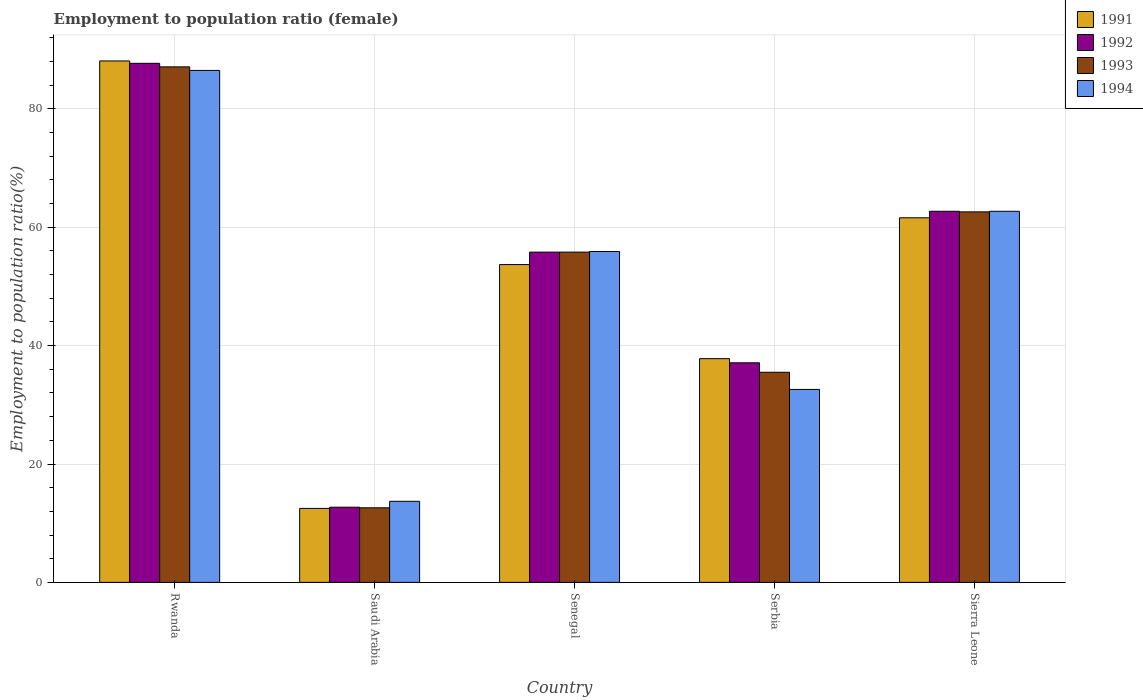How many different coloured bars are there?
Provide a succinct answer. 4. Are the number of bars per tick equal to the number of legend labels?
Provide a short and direct response. Yes. Are the number of bars on each tick of the X-axis equal?
Ensure brevity in your answer.  Yes. How many bars are there on the 3rd tick from the right?
Keep it short and to the point. 4. What is the label of the 4th group of bars from the left?
Offer a terse response. Serbia. What is the employment to population ratio in 1992 in Sierra Leone?
Provide a succinct answer. 62.7. Across all countries, what is the maximum employment to population ratio in 1993?
Make the answer very short. 87.1. Across all countries, what is the minimum employment to population ratio in 1994?
Give a very brief answer. 13.7. In which country was the employment to population ratio in 1991 maximum?
Offer a terse response. Rwanda. In which country was the employment to population ratio in 1992 minimum?
Make the answer very short. Saudi Arabia. What is the total employment to population ratio in 1991 in the graph?
Provide a short and direct response. 253.7. What is the difference between the employment to population ratio in 1994 in Rwanda and that in Saudi Arabia?
Provide a succinct answer. 72.8. What is the difference between the employment to population ratio in 1991 in Rwanda and the employment to population ratio in 1993 in Saudi Arabia?
Ensure brevity in your answer.  75.5. What is the average employment to population ratio in 1991 per country?
Your response must be concise. 50.74. What is the difference between the employment to population ratio of/in 1994 and employment to population ratio of/in 1992 in Rwanda?
Your answer should be compact. -1.2. In how many countries, is the employment to population ratio in 1992 greater than 52 %?
Offer a very short reply. 3. What is the ratio of the employment to population ratio in 1994 in Saudi Arabia to that in Sierra Leone?
Provide a short and direct response. 0.22. Is the employment to population ratio in 1994 in Saudi Arabia less than that in Sierra Leone?
Provide a short and direct response. Yes. What is the difference between the highest and the second highest employment to population ratio in 1992?
Give a very brief answer. -6.9. What is the difference between the highest and the lowest employment to population ratio in 1993?
Provide a succinct answer. 74.5. In how many countries, is the employment to population ratio in 1993 greater than the average employment to population ratio in 1993 taken over all countries?
Your response must be concise. 3. Is the sum of the employment to population ratio in 1992 in Rwanda and Sierra Leone greater than the maximum employment to population ratio in 1993 across all countries?
Make the answer very short. Yes. Is it the case that in every country, the sum of the employment to population ratio in 1994 and employment to population ratio in 1993 is greater than the sum of employment to population ratio in 1991 and employment to population ratio in 1992?
Keep it short and to the point. No. What does the 4th bar from the left in Rwanda represents?
Provide a short and direct response. 1994. What does the 2nd bar from the right in Senegal represents?
Give a very brief answer. 1993. How many bars are there?
Your answer should be very brief. 20. Are the values on the major ticks of Y-axis written in scientific E-notation?
Your response must be concise. No. Does the graph contain any zero values?
Your answer should be compact. No. How many legend labels are there?
Your answer should be compact. 4. How are the legend labels stacked?
Make the answer very short. Vertical. What is the title of the graph?
Give a very brief answer. Employment to population ratio (female). Does "1966" appear as one of the legend labels in the graph?
Your response must be concise. No. What is the label or title of the Y-axis?
Your answer should be compact. Employment to population ratio(%). What is the Employment to population ratio(%) in 1991 in Rwanda?
Your response must be concise. 88.1. What is the Employment to population ratio(%) of 1992 in Rwanda?
Your answer should be compact. 87.7. What is the Employment to population ratio(%) in 1993 in Rwanda?
Provide a short and direct response. 87.1. What is the Employment to population ratio(%) of 1994 in Rwanda?
Keep it short and to the point. 86.5. What is the Employment to population ratio(%) in 1992 in Saudi Arabia?
Your answer should be compact. 12.7. What is the Employment to population ratio(%) in 1993 in Saudi Arabia?
Your answer should be compact. 12.6. What is the Employment to population ratio(%) in 1994 in Saudi Arabia?
Your response must be concise. 13.7. What is the Employment to population ratio(%) of 1991 in Senegal?
Your answer should be very brief. 53.7. What is the Employment to population ratio(%) of 1992 in Senegal?
Keep it short and to the point. 55.8. What is the Employment to population ratio(%) of 1993 in Senegal?
Your answer should be compact. 55.8. What is the Employment to population ratio(%) in 1994 in Senegal?
Make the answer very short. 55.9. What is the Employment to population ratio(%) of 1991 in Serbia?
Your answer should be very brief. 37.8. What is the Employment to population ratio(%) of 1992 in Serbia?
Provide a succinct answer. 37.1. What is the Employment to population ratio(%) in 1993 in Serbia?
Give a very brief answer. 35.5. What is the Employment to population ratio(%) in 1994 in Serbia?
Your response must be concise. 32.6. What is the Employment to population ratio(%) of 1991 in Sierra Leone?
Make the answer very short. 61.6. What is the Employment to population ratio(%) in 1992 in Sierra Leone?
Give a very brief answer. 62.7. What is the Employment to population ratio(%) of 1993 in Sierra Leone?
Give a very brief answer. 62.6. What is the Employment to population ratio(%) of 1994 in Sierra Leone?
Your response must be concise. 62.7. Across all countries, what is the maximum Employment to population ratio(%) of 1991?
Keep it short and to the point. 88.1. Across all countries, what is the maximum Employment to population ratio(%) of 1992?
Your answer should be compact. 87.7. Across all countries, what is the maximum Employment to population ratio(%) in 1993?
Offer a very short reply. 87.1. Across all countries, what is the maximum Employment to population ratio(%) in 1994?
Your response must be concise. 86.5. Across all countries, what is the minimum Employment to population ratio(%) in 1991?
Keep it short and to the point. 12.5. Across all countries, what is the minimum Employment to population ratio(%) of 1992?
Provide a succinct answer. 12.7. Across all countries, what is the minimum Employment to population ratio(%) of 1993?
Give a very brief answer. 12.6. Across all countries, what is the minimum Employment to population ratio(%) in 1994?
Make the answer very short. 13.7. What is the total Employment to population ratio(%) in 1991 in the graph?
Your response must be concise. 253.7. What is the total Employment to population ratio(%) in 1992 in the graph?
Ensure brevity in your answer.  256. What is the total Employment to population ratio(%) in 1993 in the graph?
Provide a short and direct response. 253.6. What is the total Employment to population ratio(%) in 1994 in the graph?
Keep it short and to the point. 251.4. What is the difference between the Employment to population ratio(%) in 1991 in Rwanda and that in Saudi Arabia?
Offer a terse response. 75.6. What is the difference between the Employment to population ratio(%) in 1993 in Rwanda and that in Saudi Arabia?
Offer a terse response. 74.5. What is the difference between the Employment to population ratio(%) of 1994 in Rwanda and that in Saudi Arabia?
Provide a short and direct response. 72.8. What is the difference between the Employment to population ratio(%) of 1991 in Rwanda and that in Senegal?
Provide a short and direct response. 34.4. What is the difference between the Employment to population ratio(%) of 1992 in Rwanda and that in Senegal?
Keep it short and to the point. 31.9. What is the difference between the Employment to population ratio(%) in 1993 in Rwanda and that in Senegal?
Provide a short and direct response. 31.3. What is the difference between the Employment to population ratio(%) of 1994 in Rwanda and that in Senegal?
Offer a terse response. 30.6. What is the difference between the Employment to population ratio(%) in 1991 in Rwanda and that in Serbia?
Ensure brevity in your answer.  50.3. What is the difference between the Employment to population ratio(%) in 1992 in Rwanda and that in Serbia?
Offer a very short reply. 50.6. What is the difference between the Employment to population ratio(%) in 1993 in Rwanda and that in Serbia?
Give a very brief answer. 51.6. What is the difference between the Employment to population ratio(%) in 1994 in Rwanda and that in Serbia?
Offer a terse response. 53.9. What is the difference between the Employment to population ratio(%) of 1992 in Rwanda and that in Sierra Leone?
Your response must be concise. 25. What is the difference between the Employment to population ratio(%) in 1994 in Rwanda and that in Sierra Leone?
Make the answer very short. 23.8. What is the difference between the Employment to population ratio(%) in 1991 in Saudi Arabia and that in Senegal?
Keep it short and to the point. -41.2. What is the difference between the Employment to population ratio(%) in 1992 in Saudi Arabia and that in Senegal?
Give a very brief answer. -43.1. What is the difference between the Employment to population ratio(%) in 1993 in Saudi Arabia and that in Senegal?
Your answer should be compact. -43.2. What is the difference between the Employment to population ratio(%) of 1994 in Saudi Arabia and that in Senegal?
Offer a terse response. -42.2. What is the difference between the Employment to population ratio(%) of 1991 in Saudi Arabia and that in Serbia?
Give a very brief answer. -25.3. What is the difference between the Employment to population ratio(%) in 1992 in Saudi Arabia and that in Serbia?
Provide a succinct answer. -24.4. What is the difference between the Employment to population ratio(%) of 1993 in Saudi Arabia and that in Serbia?
Ensure brevity in your answer.  -22.9. What is the difference between the Employment to population ratio(%) in 1994 in Saudi Arabia and that in Serbia?
Your answer should be very brief. -18.9. What is the difference between the Employment to population ratio(%) in 1991 in Saudi Arabia and that in Sierra Leone?
Provide a succinct answer. -49.1. What is the difference between the Employment to population ratio(%) of 1993 in Saudi Arabia and that in Sierra Leone?
Your answer should be very brief. -50. What is the difference between the Employment to population ratio(%) in 1994 in Saudi Arabia and that in Sierra Leone?
Make the answer very short. -49. What is the difference between the Employment to population ratio(%) of 1993 in Senegal and that in Serbia?
Your answer should be compact. 20.3. What is the difference between the Employment to population ratio(%) of 1994 in Senegal and that in Serbia?
Make the answer very short. 23.3. What is the difference between the Employment to population ratio(%) of 1991 in Senegal and that in Sierra Leone?
Your answer should be compact. -7.9. What is the difference between the Employment to population ratio(%) of 1992 in Senegal and that in Sierra Leone?
Provide a succinct answer. -6.9. What is the difference between the Employment to population ratio(%) in 1994 in Senegal and that in Sierra Leone?
Provide a succinct answer. -6.8. What is the difference between the Employment to population ratio(%) in 1991 in Serbia and that in Sierra Leone?
Provide a short and direct response. -23.8. What is the difference between the Employment to population ratio(%) of 1992 in Serbia and that in Sierra Leone?
Ensure brevity in your answer.  -25.6. What is the difference between the Employment to population ratio(%) in 1993 in Serbia and that in Sierra Leone?
Keep it short and to the point. -27.1. What is the difference between the Employment to population ratio(%) of 1994 in Serbia and that in Sierra Leone?
Your answer should be compact. -30.1. What is the difference between the Employment to population ratio(%) of 1991 in Rwanda and the Employment to population ratio(%) of 1992 in Saudi Arabia?
Provide a short and direct response. 75.4. What is the difference between the Employment to population ratio(%) of 1991 in Rwanda and the Employment to population ratio(%) of 1993 in Saudi Arabia?
Keep it short and to the point. 75.5. What is the difference between the Employment to population ratio(%) of 1991 in Rwanda and the Employment to population ratio(%) of 1994 in Saudi Arabia?
Offer a terse response. 74.4. What is the difference between the Employment to population ratio(%) of 1992 in Rwanda and the Employment to population ratio(%) of 1993 in Saudi Arabia?
Ensure brevity in your answer.  75.1. What is the difference between the Employment to population ratio(%) of 1992 in Rwanda and the Employment to population ratio(%) of 1994 in Saudi Arabia?
Give a very brief answer. 74. What is the difference between the Employment to population ratio(%) in 1993 in Rwanda and the Employment to population ratio(%) in 1994 in Saudi Arabia?
Your answer should be very brief. 73.4. What is the difference between the Employment to population ratio(%) in 1991 in Rwanda and the Employment to population ratio(%) in 1992 in Senegal?
Offer a terse response. 32.3. What is the difference between the Employment to population ratio(%) of 1991 in Rwanda and the Employment to population ratio(%) of 1993 in Senegal?
Provide a succinct answer. 32.3. What is the difference between the Employment to population ratio(%) of 1991 in Rwanda and the Employment to population ratio(%) of 1994 in Senegal?
Your answer should be very brief. 32.2. What is the difference between the Employment to population ratio(%) of 1992 in Rwanda and the Employment to population ratio(%) of 1993 in Senegal?
Your answer should be compact. 31.9. What is the difference between the Employment to population ratio(%) in 1992 in Rwanda and the Employment to population ratio(%) in 1994 in Senegal?
Keep it short and to the point. 31.8. What is the difference between the Employment to population ratio(%) of 1993 in Rwanda and the Employment to population ratio(%) of 1994 in Senegal?
Keep it short and to the point. 31.2. What is the difference between the Employment to population ratio(%) of 1991 in Rwanda and the Employment to population ratio(%) of 1993 in Serbia?
Provide a short and direct response. 52.6. What is the difference between the Employment to population ratio(%) of 1991 in Rwanda and the Employment to population ratio(%) of 1994 in Serbia?
Provide a succinct answer. 55.5. What is the difference between the Employment to population ratio(%) of 1992 in Rwanda and the Employment to population ratio(%) of 1993 in Serbia?
Provide a short and direct response. 52.2. What is the difference between the Employment to population ratio(%) of 1992 in Rwanda and the Employment to population ratio(%) of 1994 in Serbia?
Your response must be concise. 55.1. What is the difference between the Employment to population ratio(%) in 1993 in Rwanda and the Employment to population ratio(%) in 1994 in Serbia?
Make the answer very short. 54.5. What is the difference between the Employment to population ratio(%) of 1991 in Rwanda and the Employment to population ratio(%) of 1992 in Sierra Leone?
Offer a terse response. 25.4. What is the difference between the Employment to population ratio(%) in 1991 in Rwanda and the Employment to population ratio(%) in 1994 in Sierra Leone?
Give a very brief answer. 25.4. What is the difference between the Employment to population ratio(%) of 1992 in Rwanda and the Employment to population ratio(%) of 1993 in Sierra Leone?
Your answer should be very brief. 25.1. What is the difference between the Employment to population ratio(%) in 1993 in Rwanda and the Employment to population ratio(%) in 1994 in Sierra Leone?
Give a very brief answer. 24.4. What is the difference between the Employment to population ratio(%) of 1991 in Saudi Arabia and the Employment to population ratio(%) of 1992 in Senegal?
Provide a succinct answer. -43.3. What is the difference between the Employment to population ratio(%) of 1991 in Saudi Arabia and the Employment to population ratio(%) of 1993 in Senegal?
Your response must be concise. -43.3. What is the difference between the Employment to population ratio(%) in 1991 in Saudi Arabia and the Employment to population ratio(%) in 1994 in Senegal?
Ensure brevity in your answer.  -43.4. What is the difference between the Employment to population ratio(%) of 1992 in Saudi Arabia and the Employment to population ratio(%) of 1993 in Senegal?
Offer a very short reply. -43.1. What is the difference between the Employment to population ratio(%) in 1992 in Saudi Arabia and the Employment to population ratio(%) in 1994 in Senegal?
Make the answer very short. -43.2. What is the difference between the Employment to population ratio(%) in 1993 in Saudi Arabia and the Employment to population ratio(%) in 1994 in Senegal?
Give a very brief answer. -43.3. What is the difference between the Employment to population ratio(%) in 1991 in Saudi Arabia and the Employment to population ratio(%) in 1992 in Serbia?
Offer a very short reply. -24.6. What is the difference between the Employment to population ratio(%) in 1991 in Saudi Arabia and the Employment to population ratio(%) in 1993 in Serbia?
Your answer should be compact. -23. What is the difference between the Employment to population ratio(%) of 1991 in Saudi Arabia and the Employment to population ratio(%) of 1994 in Serbia?
Offer a very short reply. -20.1. What is the difference between the Employment to population ratio(%) of 1992 in Saudi Arabia and the Employment to population ratio(%) of 1993 in Serbia?
Make the answer very short. -22.8. What is the difference between the Employment to population ratio(%) in 1992 in Saudi Arabia and the Employment to population ratio(%) in 1994 in Serbia?
Keep it short and to the point. -19.9. What is the difference between the Employment to population ratio(%) of 1993 in Saudi Arabia and the Employment to population ratio(%) of 1994 in Serbia?
Offer a very short reply. -20. What is the difference between the Employment to population ratio(%) of 1991 in Saudi Arabia and the Employment to population ratio(%) of 1992 in Sierra Leone?
Your answer should be compact. -50.2. What is the difference between the Employment to population ratio(%) of 1991 in Saudi Arabia and the Employment to population ratio(%) of 1993 in Sierra Leone?
Offer a very short reply. -50.1. What is the difference between the Employment to population ratio(%) of 1991 in Saudi Arabia and the Employment to population ratio(%) of 1994 in Sierra Leone?
Your response must be concise. -50.2. What is the difference between the Employment to population ratio(%) in 1992 in Saudi Arabia and the Employment to population ratio(%) in 1993 in Sierra Leone?
Keep it short and to the point. -49.9. What is the difference between the Employment to population ratio(%) of 1993 in Saudi Arabia and the Employment to population ratio(%) of 1994 in Sierra Leone?
Give a very brief answer. -50.1. What is the difference between the Employment to population ratio(%) of 1991 in Senegal and the Employment to population ratio(%) of 1994 in Serbia?
Offer a terse response. 21.1. What is the difference between the Employment to population ratio(%) of 1992 in Senegal and the Employment to population ratio(%) of 1993 in Serbia?
Provide a succinct answer. 20.3. What is the difference between the Employment to population ratio(%) in 1992 in Senegal and the Employment to population ratio(%) in 1994 in Serbia?
Your response must be concise. 23.2. What is the difference between the Employment to population ratio(%) in 1993 in Senegal and the Employment to population ratio(%) in 1994 in Serbia?
Keep it short and to the point. 23.2. What is the difference between the Employment to population ratio(%) in 1991 in Senegal and the Employment to population ratio(%) in 1992 in Sierra Leone?
Make the answer very short. -9. What is the difference between the Employment to population ratio(%) in 1991 in Senegal and the Employment to population ratio(%) in 1993 in Sierra Leone?
Your answer should be very brief. -8.9. What is the difference between the Employment to population ratio(%) in 1992 in Senegal and the Employment to population ratio(%) in 1994 in Sierra Leone?
Ensure brevity in your answer.  -6.9. What is the difference between the Employment to population ratio(%) in 1991 in Serbia and the Employment to population ratio(%) in 1992 in Sierra Leone?
Ensure brevity in your answer.  -24.9. What is the difference between the Employment to population ratio(%) of 1991 in Serbia and the Employment to population ratio(%) of 1993 in Sierra Leone?
Make the answer very short. -24.8. What is the difference between the Employment to population ratio(%) in 1991 in Serbia and the Employment to population ratio(%) in 1994 in Sierra Leone?
Offer a terse response. -24.9. What is the difference between the Employment to population ratio(%) in 1992 in Serbia and the Employment to population ratio(%) in 1993 in Sierra Leone?
Provide a short and direct response. -25.5. What is the difference between the Employment to population ratio(%) of 1992 in Serbia and the Employment to population ratio(%) of 1994 in Sierra Leone?
Your answer should be very brief. -25.6. What is the difference between the Employment to population ratio(%) of 1993 in Serbia and the Employment to population ratio(%) of 1994 in Sierra Leone?
Your answer should be very brief. -27.2. What is the average Employment to population ratio(%) of 1991 per country?
Your answer should be compact. 50.74. What is the average Employment to population ratio(%) in 1992 per country?
Offer a very short reply. 51.2. What is the average Employment to population ratio(%) in 1993 per country?
Offer a terse response. 50.72. What is the average Employment to population ratio(%) in 1994 per country?
Provide a short and direct response. 50.28. What is the difference between the Employment to population ratio(%) in 1991 and Employment to population ratio(%) in 1992 in Rwanda?
Make the answer very short. 0.4. What is the difference between the Employment to population ratio(%) in 1991 and Employment to population ratio(%) in 1993 in Rwanda?
Your answer should be very brief. 1. What is the difference between the Employment to population ratio(%) in 1992 and Employment to population ratio(%) in 1994 in Rwanda?
Your response must be concise. 1.2. What is the difference between the Employment to population ratio(%) of 1991 and Employment to population ratio(%) of 1992 in Saudi Arabia?
Make the answer very short. -0.2. What is the difference between the Employment to population ratio(%) in 1991 and Employment to population ratio(%) in 1993 in Saudi Arabia?
Make the answer very short. -0.1. What is the difference between the Employment to population ratio(%) of 1991 and Employment to population ratio(%) of 1994 in Saudi Arabia?
Provide a short and direct response. -1.2. What is the difference between the Employment to population ratio(%) in 1993 and Employment to population ratio(%) in 1994 in Saudi Arabia?
Provide a succinct answer. -1.1. What is the difference between the Employment to population ratio(%) in 1991 and Employment to population ratio(%) in 1992 in Senegal?
Your answer should be compact. -2.1. What is the difference between the Employment to population ratio(%) in 1991 and Employment to population ratio(%) in 1994 in Senegal?
Your response must be concise. -2.2. What is the difference between the Employment to population ratio(%) of 1992 and Employment to population ratio(%) of 1993 in Senegal?
Make the answer very short. 0. What is the difference between the Employment to population ratio(%) of 1993 and Employment to population ratio(%) of 1994 in Senegal?
Offer a terse response. -0.1. What is the difference between the Employment to population ratio(%) in 1991 and Employment to population ratio(%) in 1992 in Serbia?
Keep it short and to the point. 0.7. What is the difference between the Employment to population ratio(%) of 1991 and Employment to population ratio(%) of 1993 in Serbia?
Ensure brevity in your answer.  2.3. What is the ratio of the Employment to population ratio(%) of 1991 in Rwanda to that in Saudi Arabia?
Your answer should be compact. 7.05. What is the ratio of the Employment to population ratio(%) in 1992 in Rwanda to that in Saudi Arabia?
Your response must be concise. 6.91. What is the ratio of the Employment to population ratio(%) in 1993 in Rwanda to that in Saudi Arabia?
Offer a very short reply. 6.91. What is the ratio of the Employment to population ratio(%) in 1994 in Rwanda to that in Saudi Arabia?
Provide a short and direct response. 6.31. What is the ratio of the Employment to population ratio(%) of 1991 in Rwanda to that in Senegal?
Provide a short and direct response. 1.64. What is the ratio of the Employment to population ratio(%) of 1992 in Rwanda to that in Senegal?
Provide a succinct answer. 1.57. What is the ratio of the Employment to population ratio(%) of 1993 in Rwanda to that in Senegal?
Give a very brief answer. 1.56. What is the ratio of the Employment to population ratio(%) of 1994 in Rwanda to that in Senegal?
Give a very brief answer. 1.55. What is the ratio of the Employment to population ratio(%) in 1991 in Rwanda to that in Serbia?
Ensure brevity in your answer.  2.33. What is the ratio of the Employment to population ratio(%) in 1992 in Rwanda to that in Serbia?
Your response must be concise. 2.36. What is the ratio of the Employment to population ratio(%) in 1993 in Rwanda to that in Serbia?
Keep it short and to the point. 2.45. What is the ratio of the Employment to population ratio(%) in 1994 in Rwanda to that in Serbia?
Your answer should be compact. 2.65. What is the ratio of the Employment to population ratio(%) in 1991 in Rwanda to that in Sierra Leone?
Offer a very short reply. 1.43. What is the ratio of the Employment to population ratio(%) in 1992 in Rwanda to that in Sierra Leone?
Your response must be concise. 1.4. What is the ratio of the Employment to population ratio(%) of 1993 in Rwanda to that in Sierra Leone?
Your answer should be very brief. 1.39. What is the ratio of the Employment to population ratio(%) of 1994 in Rwanda to that in Sierra Leone?
Your response must be concise. 1.38. What is the ratio of the Employment to population ratio(%) in 1991 in Saudi Arabia to that in Senegal?
Keep it short and to the point. 0.23. What is the ratio of the Employment to population ratio(%) in 1992 in Saudi Arabia to that in Senegal?
Provide a succinct answer. 0.23. What is the ratio of the Employment to population ratio(%) in 1993 in Saudi Arabia to that in Senegal?
Provide a succinct answer. 0.23. What is the ratio of the Employment to population ratio(%) in 1994 in Saudi Arabia to that in Senegal?
Give a very brief answer. 0.25. What is the ratio of the Employment to population ratio(%) of 1991 in Saudi Arabia to that in Serbia?
Your response must be concise. 0.33. What is the ratio of the Employment to population ratio(%) of 1992 in Saudi Arabia to that in Serbia?
Offer a terse response. 0.34. What is the ratio of the Employment to population ratio(%) of 1993 in Saudi Arabia to that in Serbia?
Your response must be concise. 0.35. What is the ratio of the Employment to population ratio(%) of 1994 in Saudi Arabia to that in Serbia?
Offer a terse response. 0.42. What is the ratio of the Employment to population ratio(%) in 1991 in Saudi Arabia to that in Sierra Leone?
Give a very brief answer. 0.2. What is the ratio of the Employment to population ratio(%) of 1992 in Saudi Arabia to that in Sierra Leone?
Give a very brief answer. 0.2. What is the ratio of the Employment to population ratio(%) in 1993 in Saudi Arabia to that in Sierra Leone?
Provide a short and direct response. 0.2. What is the ratio of the Employment to population ratio(%) in 1994 in Saudi Arabia to that in Sierra Leone?
Offer a very short reply. 0.22. What is the ratio of the Employment to population ratio(%) in 1991 in Senegal to that in Serbia?
Your answer should be compact. 1.42. What is the ratio of the Employment to population ratio(%) in 1992 in Senegal to that in Serbia?
Ensure brevity in your answer.  1.5. What is the ratio of the Employment to population ratio(%) of 1993 in Senegal to that in Serbia?
Make the answer very short. 1.57. What is the ratio of the Employment to population ratio(%) in 1994 in Senegal to that in Serbia?
Ensure brevity in your answer.  1.71. What is the ratio of the Employment to population ratio(%) of 1991 in Senegal to that in Sierra Leone?
Give a very brief answer. 0.87. What is the ratio of the Employment to population ratio(%) of 1992 in Senegal to that in Sierra Leone?
Your answer should be very brief. 0.89. What is the ratio of the Employment to population ratio(%) in 1993 in Senegal to that in Sierra Leone?
Offer a terse response. 0.89. What is the ratio of the Employment to population ratio(%) of 1994 in Senegal to that in Sierra Leone?
Give a very brief answer. 0.89. What is the ratio of the Employment to population ratio(%) of 1991 in Serbia to that in Sierra Leone?
Offer a terse response. 0.61. What is the ratio of the Employment to population ratio(%) in 1992 in Serbia to that in Sierra Leone?
Provide a succinct answer. 0.59. What is the ratio of the Employment to population ratio(%) of 1993 in Serbia to that in Sierra Leone?
Your answer should be very brief. 0.57. What is the ratio of the Employment to population ratio(%) in 1994 in Serbia to that in Sierra Leone?
Your answer should be very brief. 0.52. What is the difference between the highest and the second highest Employment to population ratio(%) in 1991?
Offer a terse response. 26.5. What is the difference between the highest and the second highest Employment to population ratio(%) in 1994?
Give a very brief answer. 23.8. What is the difference between the highest and the lowest Employment to population ratio(%) of 1991?
Your response must be concise. 75.6. What is the difference between the highest and the lowest Employment to population ratio(%) in 1992?
Give a very brief answer. 75. What is the difference between the highest and the lowest Employment to population ratio(%) in 1993?
Provide a succinct answer. 74.5. What is the difference between the highest and the lowest Employment to population ratio(%) of 1994?
Provide a short and direct response. 72.8. 